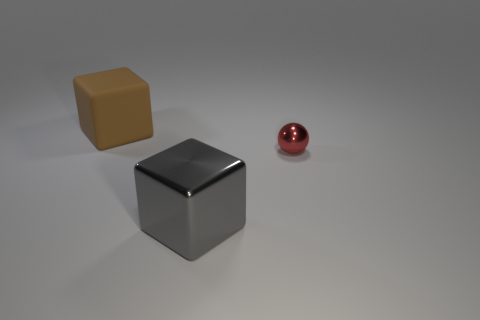What number of other things are there of the same size as the brown matte thing? In the image provided, there appears to be one other object of a similar size to the brown matte cube, which is the silver glossy cube. 